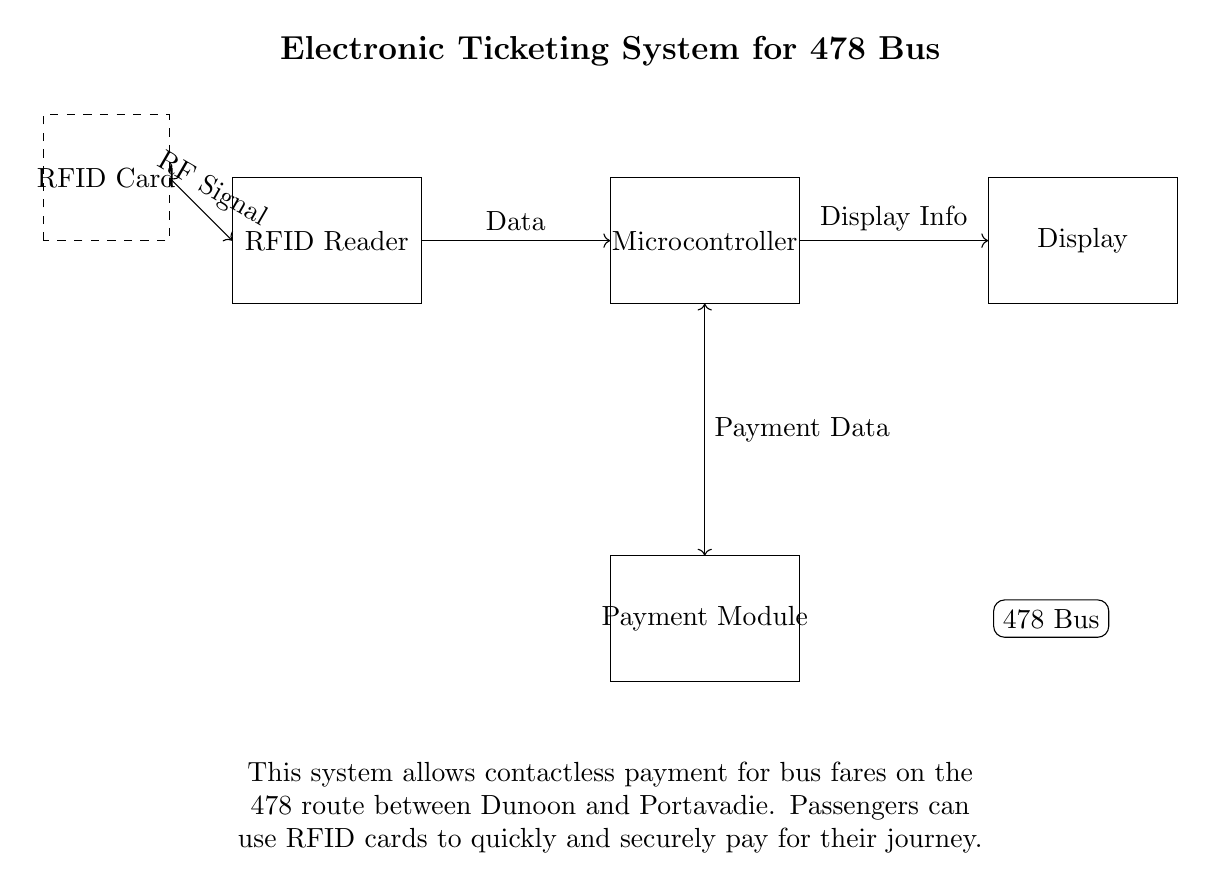What component reads the RFID data? The RFID Reader is specifically designed to read the RFID data from the RFID Card, as shown in the circuit diagram.
Answer: RFID Reader What connects the Payment Module to the Microcontroller? The Payment Data connection between the Payment Module and the Microcontroller indicates how payment information is exchanged for processing transactions.
Answer: Payment Data What type of payment does this system facilitate? This system facilitates contactless payments, as passengers can use RFID cards to pay instantaneously without physical contact.
Answer: Contactless payments How many main components are present in this circuit? The circuit includes four main components: the RFID Reader, Microcontroller, Display, and Payment Module, making a total of four elements.
Answer: Four What signals are exchanged between the RFID Card and the RFID Reader? The communication is established through RF Signal, allowing the reader to receive data from the RFID card.
Answer: RF Signal What is the purpose of the Display component in this system? The Display component shows information to the user, likely confirming payment or displaying fare details after processing data from the Microcontroller.
Answer: Display Info 